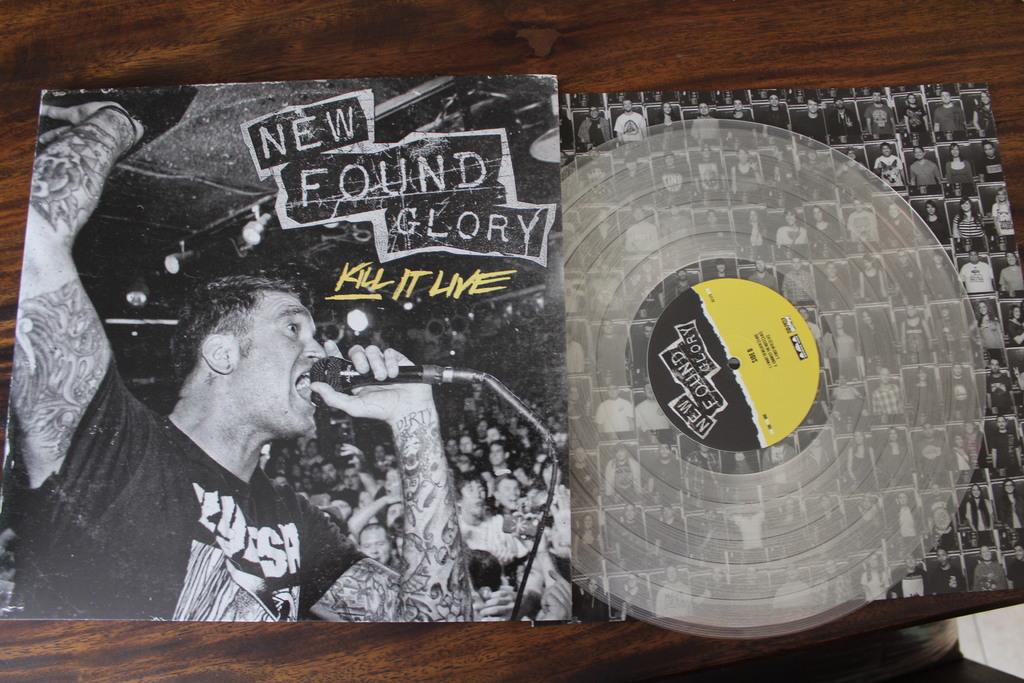What is the main object in the image? There is a cover in the image. What is inside the cover? There is a CD disk in the image. What type of surface is the cover and CD disk placed on? The wooden surface is present in the image. How does the CD disk cry in the image? The CD disk does not cry in the image, as it is an inanimate object and cannot experience emotions like crying. 